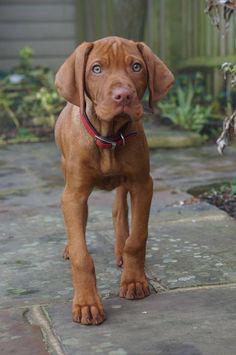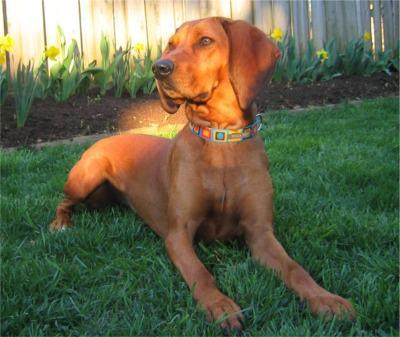The first image is the image on the left, the second image is the image on the right. Evaluate the accuracy of this statement regarding the images: "The dogs in each of the images are outside.". Is it true? Answer yes or no. Yes. The first image is the image on the left, the second image is the image on the right. For the images shown, is this caption "The left image contains at least two dogs." true? Answer yes or no. No. 